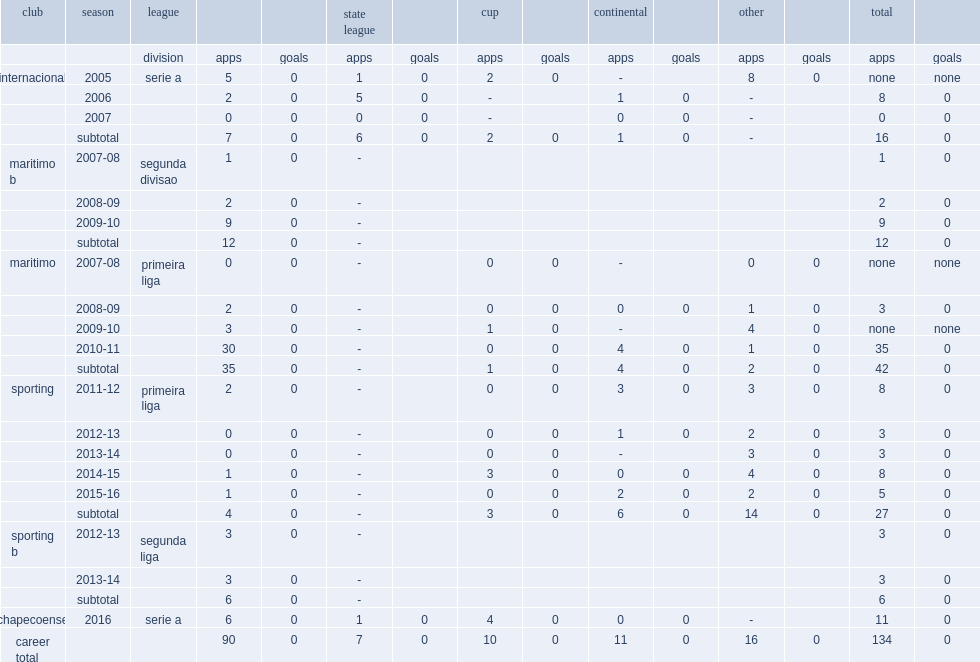Which club did marcelo boeck play for in 2016? Chapecoense. 